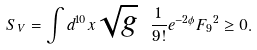<formula> <loc_0><loc_0><loc_500><loc_500>S _ { V } = \int d ^ { 1 0 } x \sqrt { g } \ { \frac { 1 } { 9 ! } } e ^ { - 2 \phi } { F _ { 9 } } ^ { 2 } \geq 0 .</formula> 